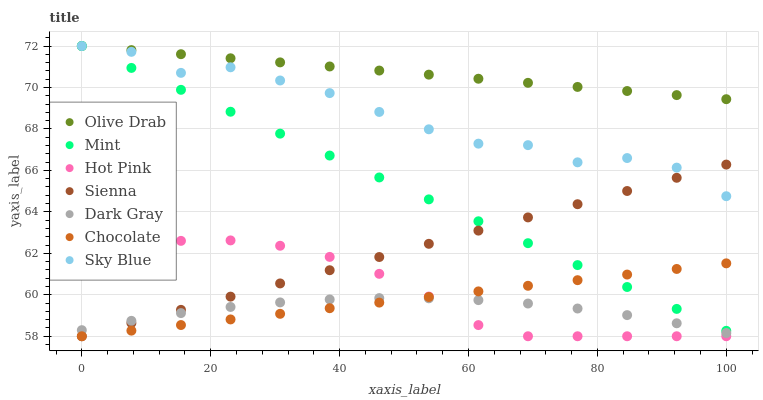Does Dark Gray have the minimum area under the curve?
Answer yes or no. Yes. Does Olive Drab have the maximum area under the curve?
Answer yes or no. Yes. Does Hot Pink have the minimum area under the curve?
Answer yes or no. No. Does Hot Pink have the maximum area under the curve?
Answer yes or no. No. Is Chocolate the smoothest?
Answer yes or no. Yes. Is Sky Blue the roughest?
Answer yes or no. Yes. Is Hot Pink the smoothest?
Answer yes or no. No. Is Hot Pink the roughest?
Answer yes or no. No. Does Hot Pink have the lowest value?
Answer yes or no. Yes. Does Sky Blue have the lowest value?
Answer yes or no. No. Does Olive Drab have the highest value?
Answer yes or no. Yes. Does Hot Pink have the highest value?
Answer yes or no. No. Is Chocolate less than Olive Drab?
Answer yes or no. Yes. Is Mint greater than Dark Gray?
Answer yes or no. Yes. Does Mint intersect Sienna?
Answer yes or no. Yes. Is Mint less than Sienna?
Answer yes or no. No. Is Mint greater than Sienna?
Answer yes or no. No. Does Chocolate intersect Olive Drab?
Answer yes or no. No. 